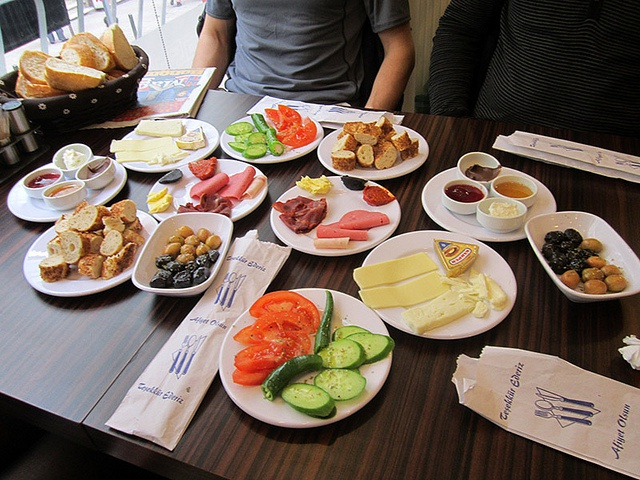Describe the objects in this image and their specific colors. I can see dining table in darkgray, black, lightgray, and tan tones, people in darkgray, black, and gray tones, people in darkgray, black, gray, and maroon tones, bowl in darkgray, black, lightgray, brown, and tan tones, and bowl in darkgray, black, lightgray, and tan tones in this image. 